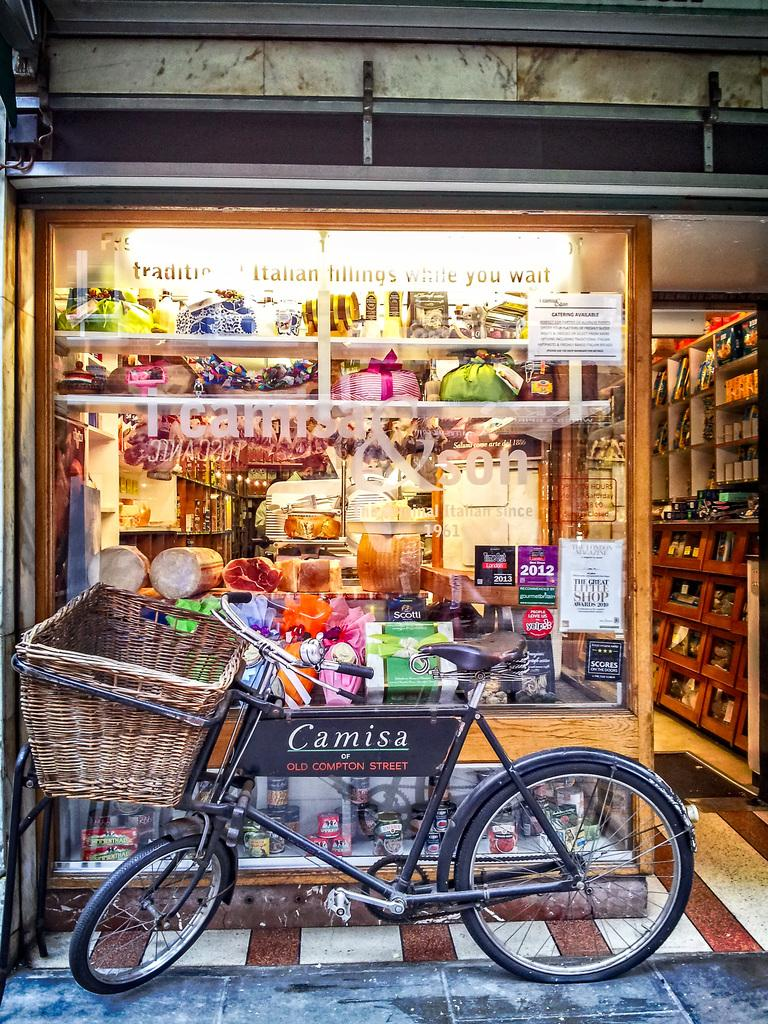<image>
Write a terse but informative summary of the picture. A bicycle with the name plate saying Camisa is in front of a stroe with colorful displays. 